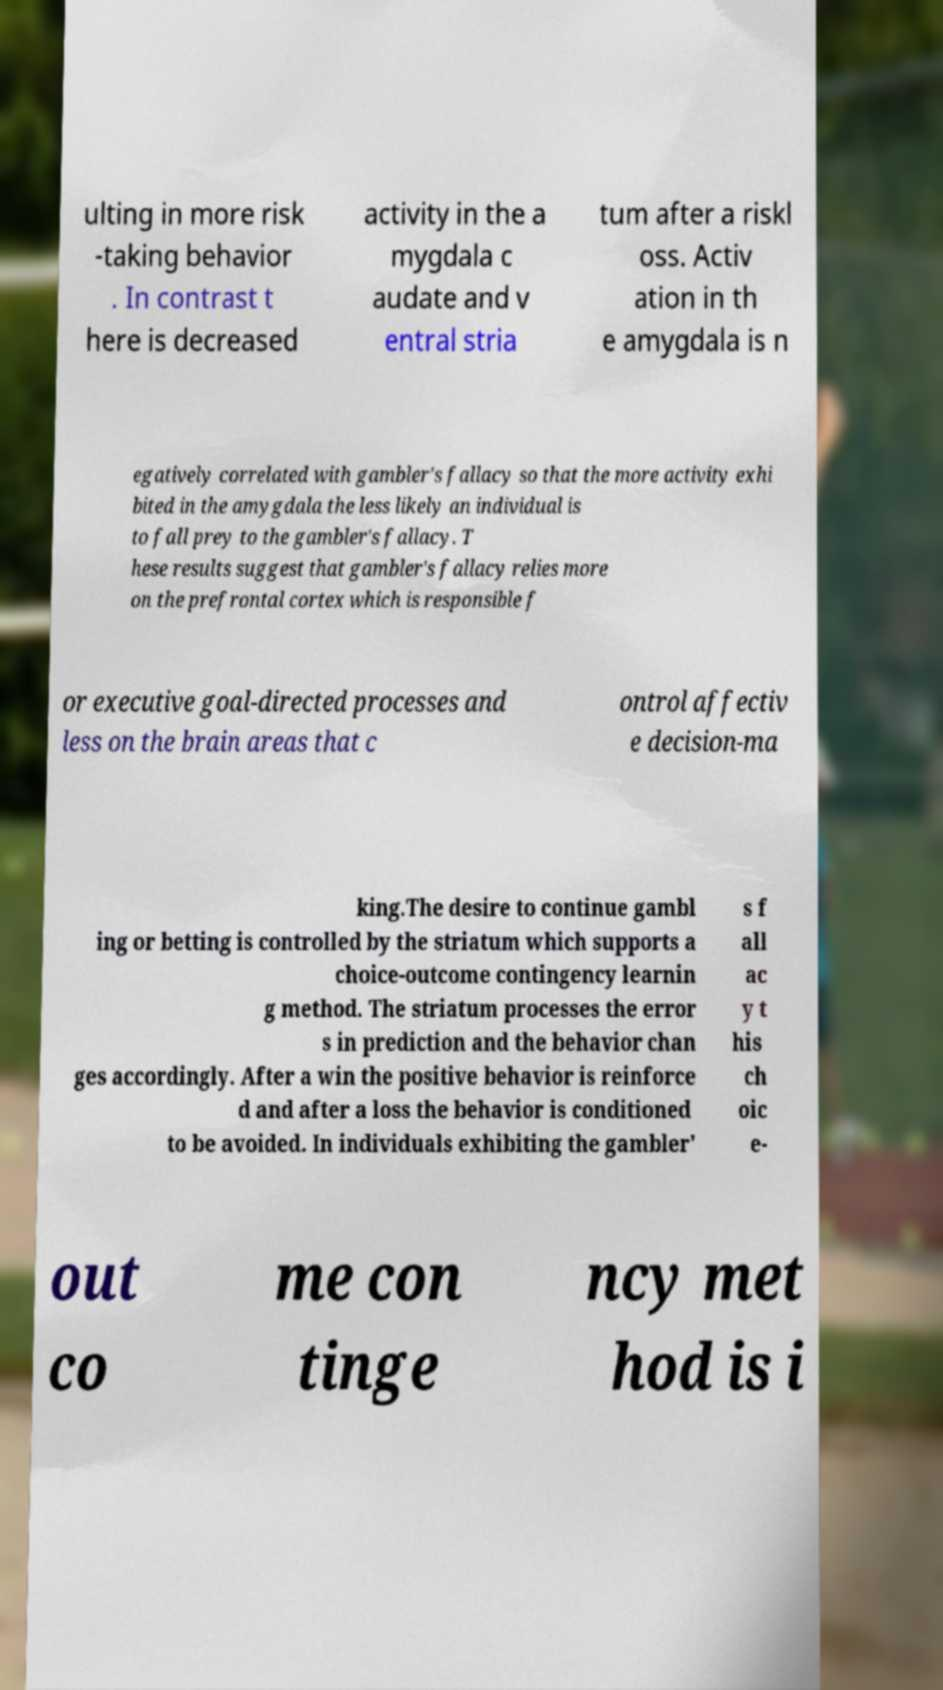I need the written content from this picture converted into text. Can you do that? ulting in more risk -taking behavior . In contrast t here is decreased activity in the a mygdala c audate and v entral stria tum after a riskl oss. Activ ation in th e amygdala is n egatively correlated with gambler's fallacy so that the more activity exhi bited in the amygdala the less likely an individual is to fall prey to the gambler's fallacy. T hese results suggest that gambler's fallacy relies more on the prefrontal cortex which is responsible f or executive goal-directed processes and less on the brain areas that c ontrol affectiv e decision-ma king.The desire to continue gambl ing or betting is controlled by the striatum which supports a choice-outcome contingency learnin g method. The striatum processes the error s in prediction and the behavior chan ges accordingly. After a win the positive behavior is reinforce d and after a loss the behavior is conditioned to be avoided. In individuals exhibiting the gambler' s f all ac y t his ch oic e- out co me con tinge ncy met hod is i 